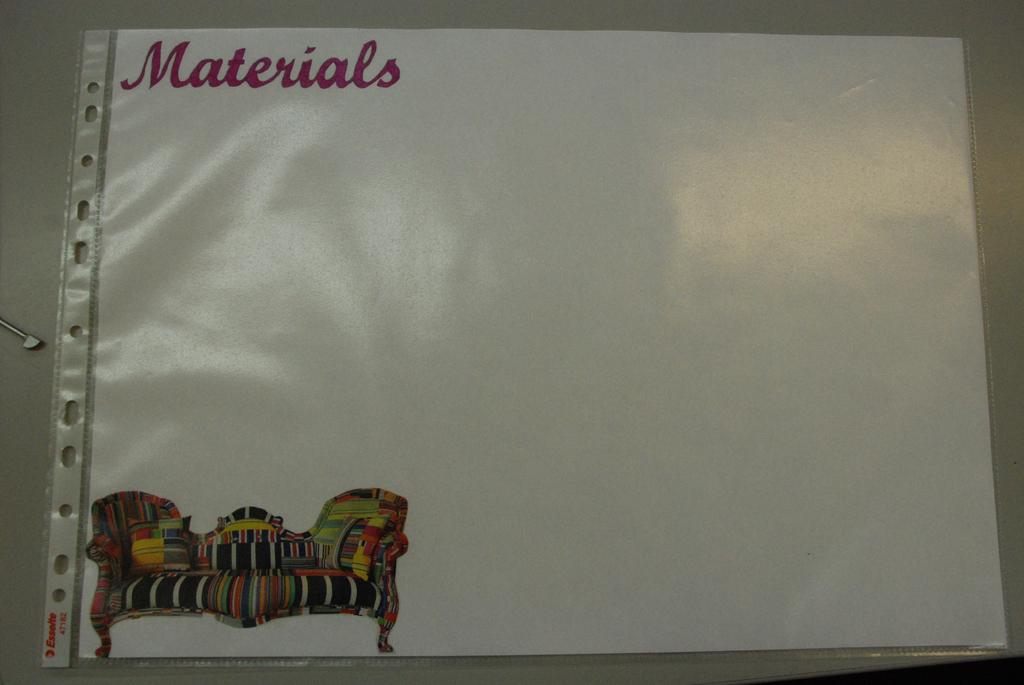What is on the plastic sleeve?
Offer a terse response. Materials. 